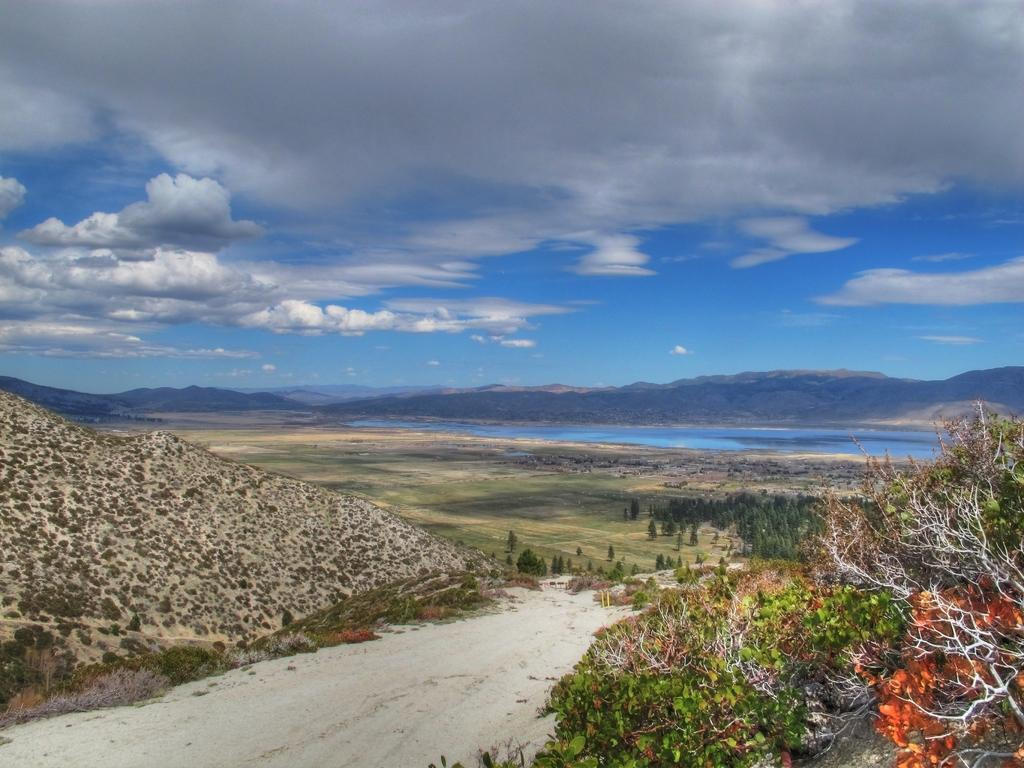What type of natural landform can be seen in the image? There are mountains in the image. What type of vegetation is present in the image? There are trees in the image. What body of water is visible in the image? There is water visible in the image. What is the color of the sky in the image? The sky is blue and white in color. Where is the fireman skating in the image? There is no fireman or skating activity present in the image. 